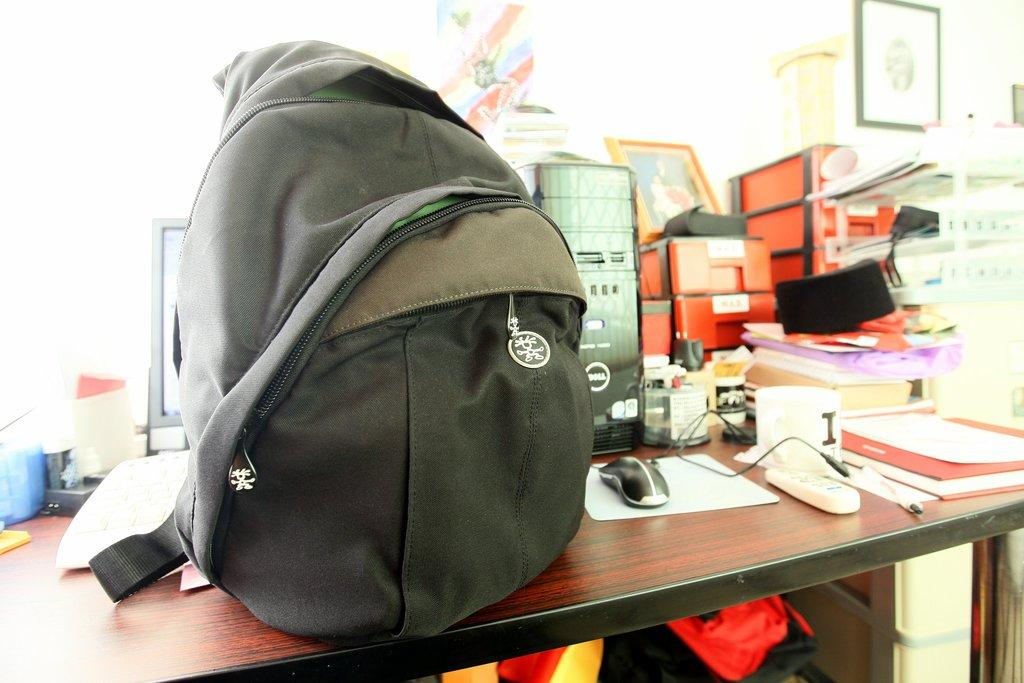What is placed on the table in the image? There is a bag and a computer on the table. Can you describe any other items on the table? There are additional unspecified items on the table. What type of rhythm can be heard coming from the bag in the image? There is no indication of sound or rhythm in the image, and the bag does not appear to be a musical instrument. 